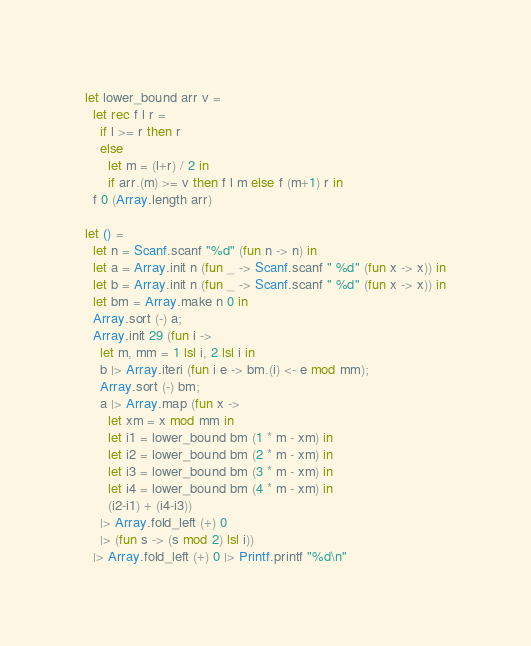Convert code to text. <code><loc_0><loc_0><loc_500><loc_500><_OCaml_>let lower_bound arr v =
  let rec f l r =
    if l >= r then r
    else
      let m = (l+r) / 2 in
      if arr.(m) >= v then f l m else f (m+1) r in
  f 0 (Array.length arr)

let () =
  let n = Scanf.scanf "%d" (fun n -> n) in
  let a = Array.init n (fun _ -> Scanf.scanf " %d" (fun x -> x)) in
  let b = Array.init n (fun _ -> Scanf.scanf " %d" (fun x -> x)) in
  let bm = Array.make n 0 in
  Array.sort (-) a;
  Array.init 29 (fun i ->
    let m, mm = 1 lsl i, 2 lsl i in
    b |> Array.iteri (fun i e -> bm.(i) <- e mod mm);
    Array.sort (-) bm;
    a |> Array.map (fun x ->
      let xm = x mod mm in
      let i1 = lower_bound bm (1 * m - xm) in
      let i2 = lower_bound bm (2 * m - xm) in
      let i3 = lower_bound bm (3 * m - xm) in
      let i4 = lower_bound bm (4 * m - xm) in
      (i2-i1) + (i4-i3))
    |> Array.fold_left (+) 0
    |> (fun s -> (s mod 2) lsl i))
  |> Array.fold_left (+) 0 |> Printf.printf "%d\n"
</code> 